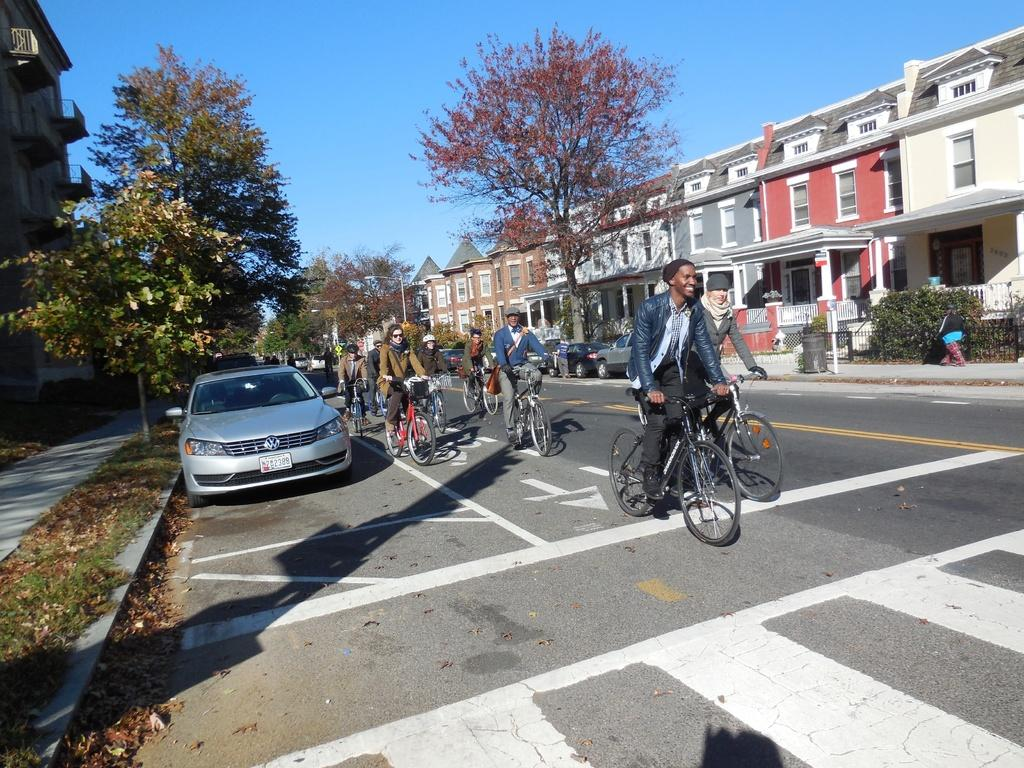What can be seen in the sky in the image? There is a sky in the image. What type of natural element is present in the image? There is a tree in the image. What type of man-made structures are visible in the image? There are buildings in the image. What mode of transportation can be seen in the image? There is a car in the image. What activity are people engaged in within the image? There are people riding bicycles in the image. How do the sticks help the people riding bicycles in the image? There are no sticks present in the image; the people are riding bicycles without any visible sticks. 